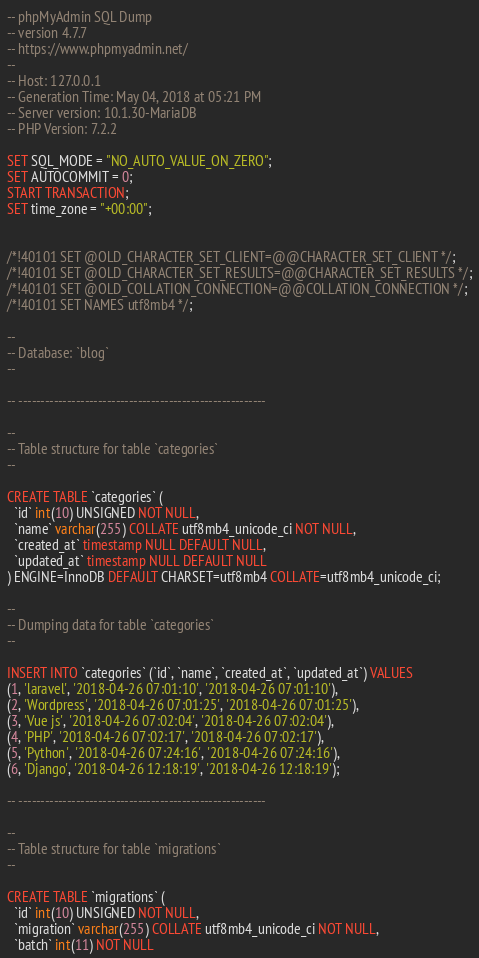Convert code to text. <code><loc_0><loc_0><loc_500><loc_500><_SQL_>-- phpMyAdmin SQL Dump
-- version 4.7.7
-- https://www.phpmyadmin.net/
--
-- Host: 127.0.0.1
-- Generation Time: May 04, 2018 at 05:21 PM
-- Server version: 10.1.30-MariaDB
-- PHP Version: 7.2.2

SET SQL_MODE = "NO_AUTO_VALUE_ON_ZERO";
SET AUTOCOMMIT = 0;
START TRANSACTION;
SET time_zone = "+00:00";


/*!40101 SET @OLD_CHARACTER_SET_CLIENT=@@CHARACTER_SET_CLIENT */;
/*!40101 SET @OLD_CHARACTER_SET_RESULTS=@@CHARACTER_SET_RESULTS */;
/*!40101 SET @OLD_COLLATION_CONNECTION=@@COLLATION_CONNECTION */;
/*!40101 SET NAMES utf8mb4 */;

--
-- Database: `blog`
--

-- --------------------------------------------------------

--
-- Table structure for table `categories`
--

CREATE TABLE `categories` (
  `id` int(10) UNSIGNED NOT NULL,
  `name` varchar(255) COLLATE utf8mb4_unicode_ci NOT NULL,
  `created_at` timestamp NULL DEFAULT NULL,
  `updated_at` timestamp NULL DEFAULT NULL
) ENGINE=InnoDB DEFAULT CHARSET=utf8mb4 COLLATE=utf8mb4_unicode_ci;

--
-- Dumping data for table `categories`
--

INSERT INTO `categories` (`id`, `name`, `created_at`, `updated_at`) VALUES
(1, 'laravel', '2018-04-26 07:01:10', '2018-04-26 07:01:10'),
(2, 'Wordpress', '2018-04-26 07:01:25', '2018-04-26 07:01:25'),
(3, 'Vue js', '2018-04-26 07:02:04', '2018-04-26 07:02:04'),
(4, 'PHP', '2018-04-26 07:02:17', '2018-04-26 07:02:17'),
(5, 'Python', '2018-04-26 07:24:16', '2018-04-26 07:24:16'),
(6, 'Django', '2018-04-26 12:18:19', '2018-04-26 12:18:19');

-- --------------------------------------------------------

--
-- Table structure for table `migrations`
--

CREATE TABLE `migrations` (
  `id` int(10) UNSIGNED NOT NULL,
  `migration` varchar(255) COLLATE utf8mb4_unicode_ci NOT NULL,
  `batch` int(11) NOT NULL</code> 